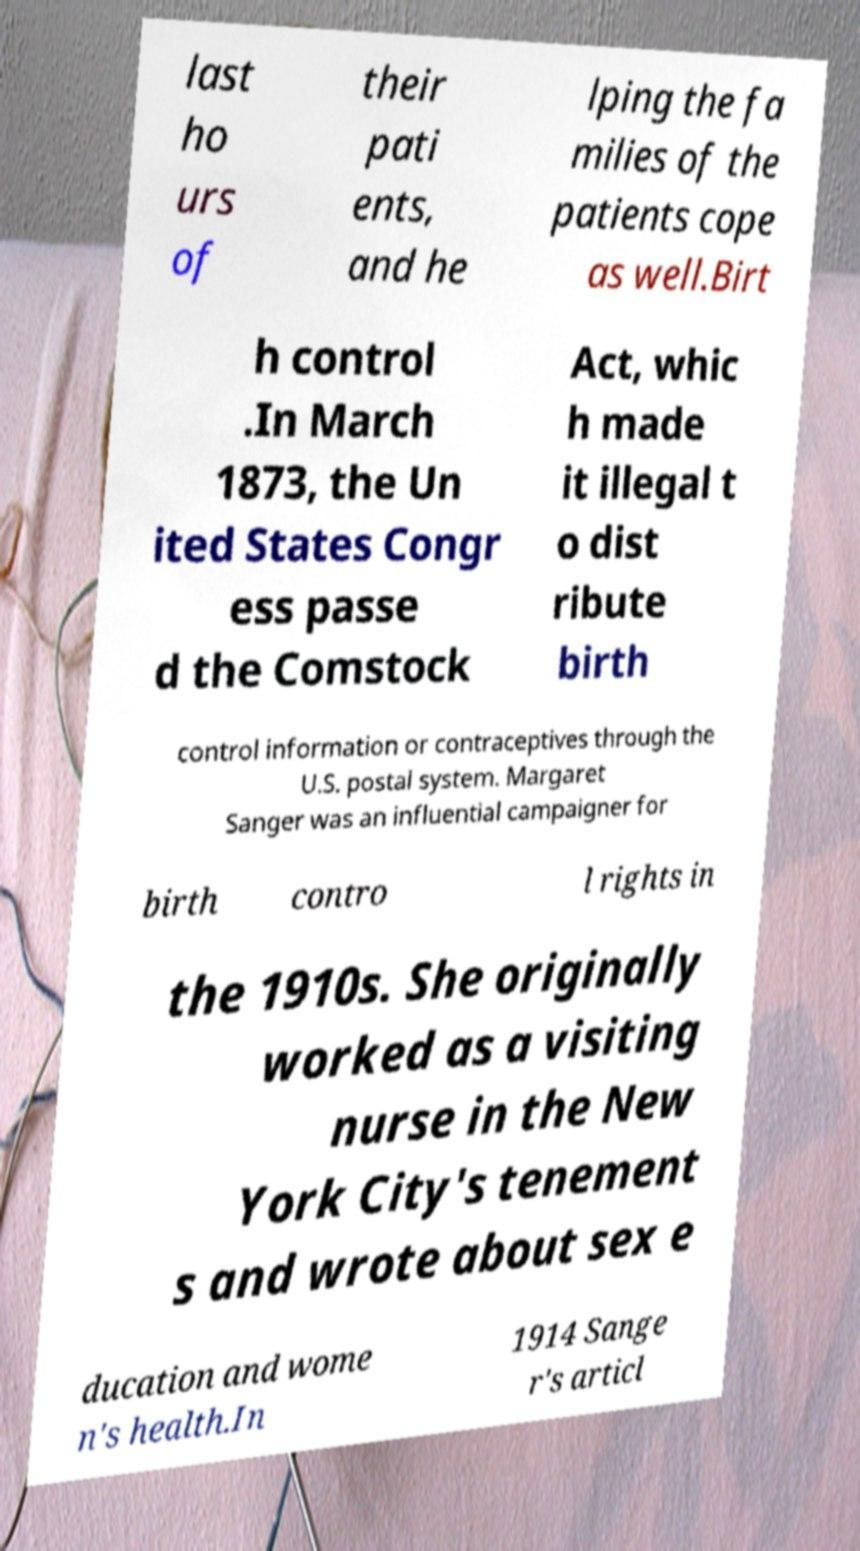Could you assist in decoding the text presented in this image and type it out clearly? last ho urs of their pati ents, and he lping the fa milies of the patients cope as well.Birt h control .In March 1873, the Un ited States Congr ess passe d the Comstock Act, whic h made it illegal t o dist ribute birth control information or contraceptives through the U.S. postal system. Margaret Sanger was an influential campaigner for birth contro l rights in the 1910s. She originally worked as a visiting nurse in the New York City's tenement s and wrote about sex e ducation and wome n's health.In 1914 Sange r's articl 